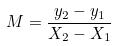Convert formula to latex. <formula><loc_0><loc_0><loc_500><loc_500>M = \frac { y _ { 2 } - y _ { 1 } } { X _ { 2 } - X _ { 1 } }</formula> 